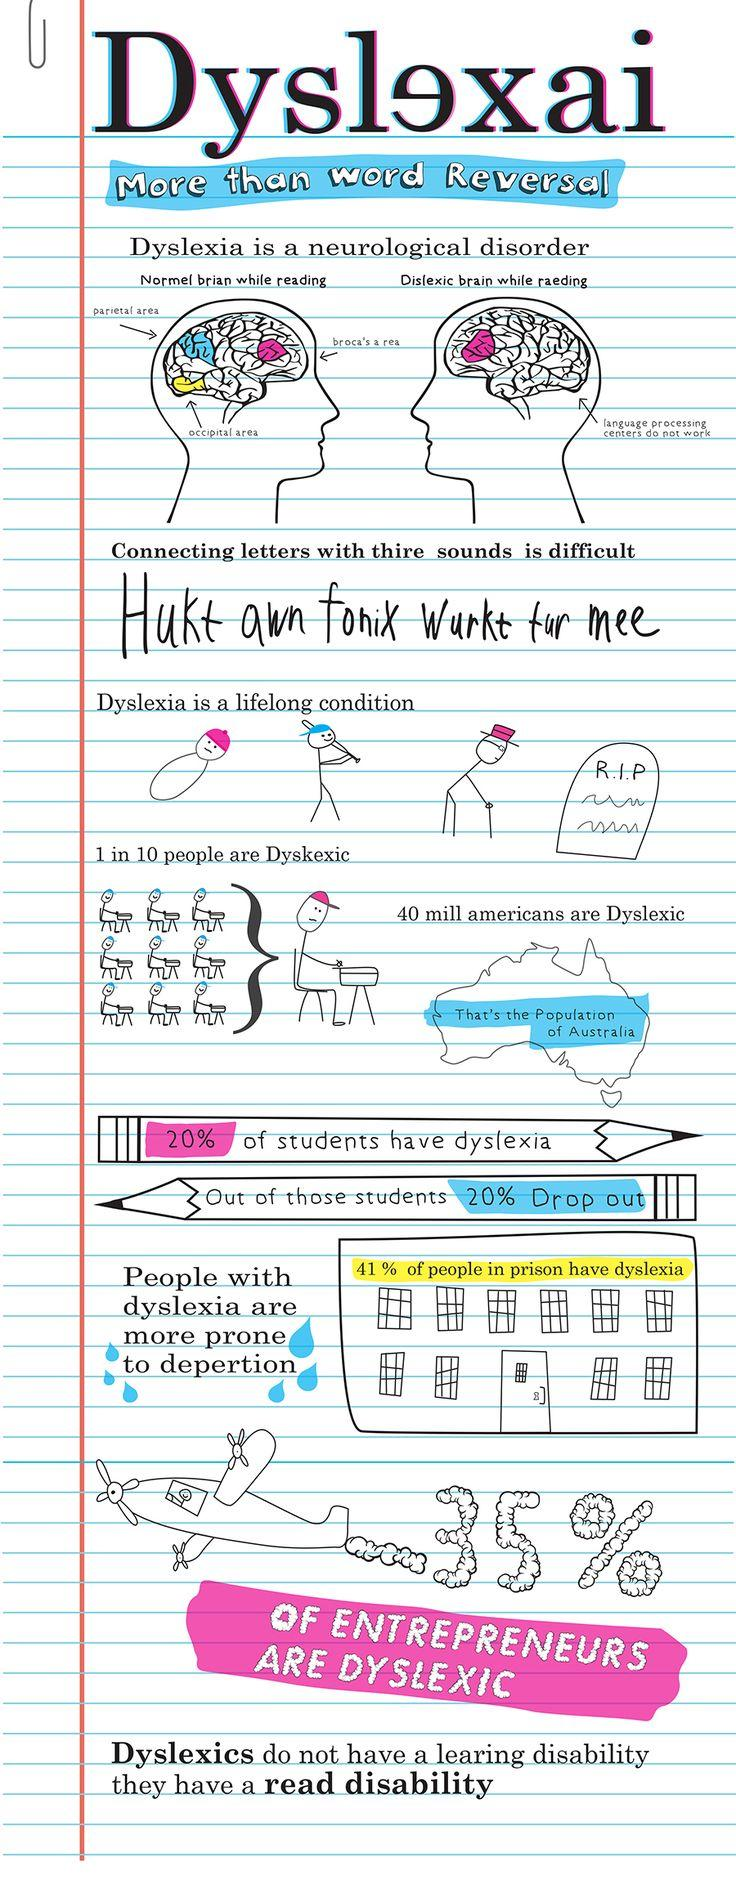Point out several critical features in this image. The Broca's area of the human brain is depicted in magenta color. The occipital area of the human brain is highlighted in yellow. The parietal area of the human brain is shown in blue color. According to a recent study, only 20% of students have dyslexia. Out of 10 people, 9 of them are not dyslexic. 